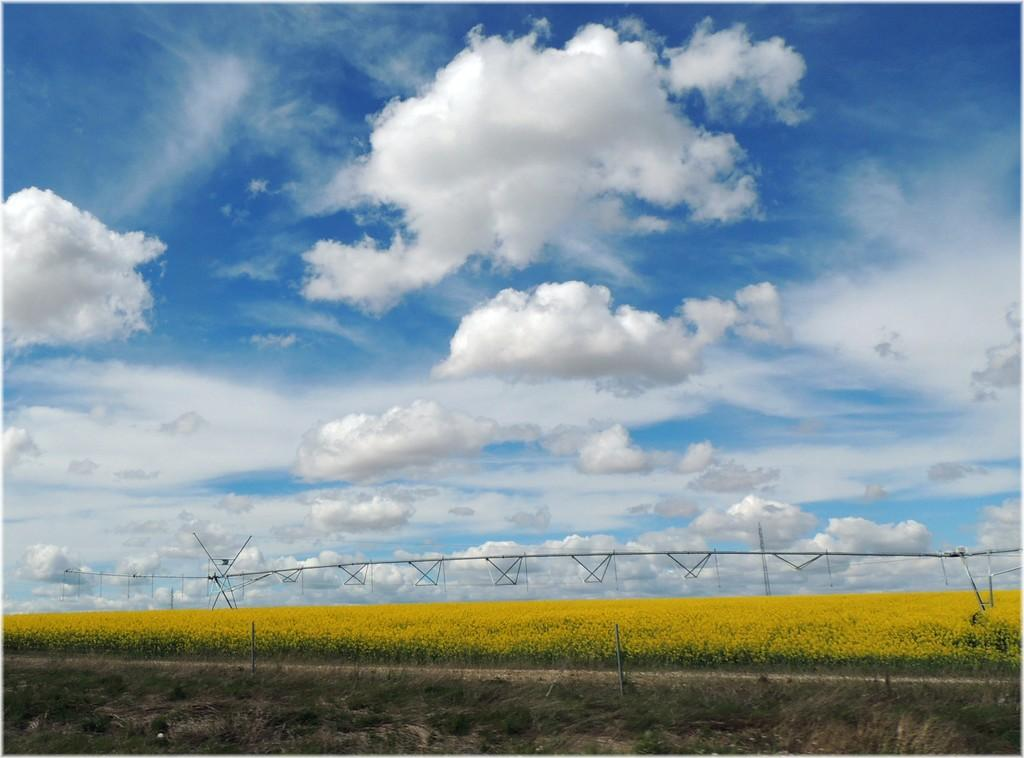What type of plants are in the middle of the image? There are flower plants in the middle of the image. What is at the bottom of the image? There is grass at the bottom of the image. What is visible at the top of the image? The sky is visible at the top of the image. What structures are present in the middle of the image? There are poles in the middle of the image. What are the poles connected to? There are wires attached to the poles. What type of stage can be seen in the image? There is no stage present in the image. What is the cause of the wires being attached to the poles in the image? The image does not provide information about the cause of the wires being attached to the poles. How many pancakes are visible in the image? There are no pancakes present in the image. 